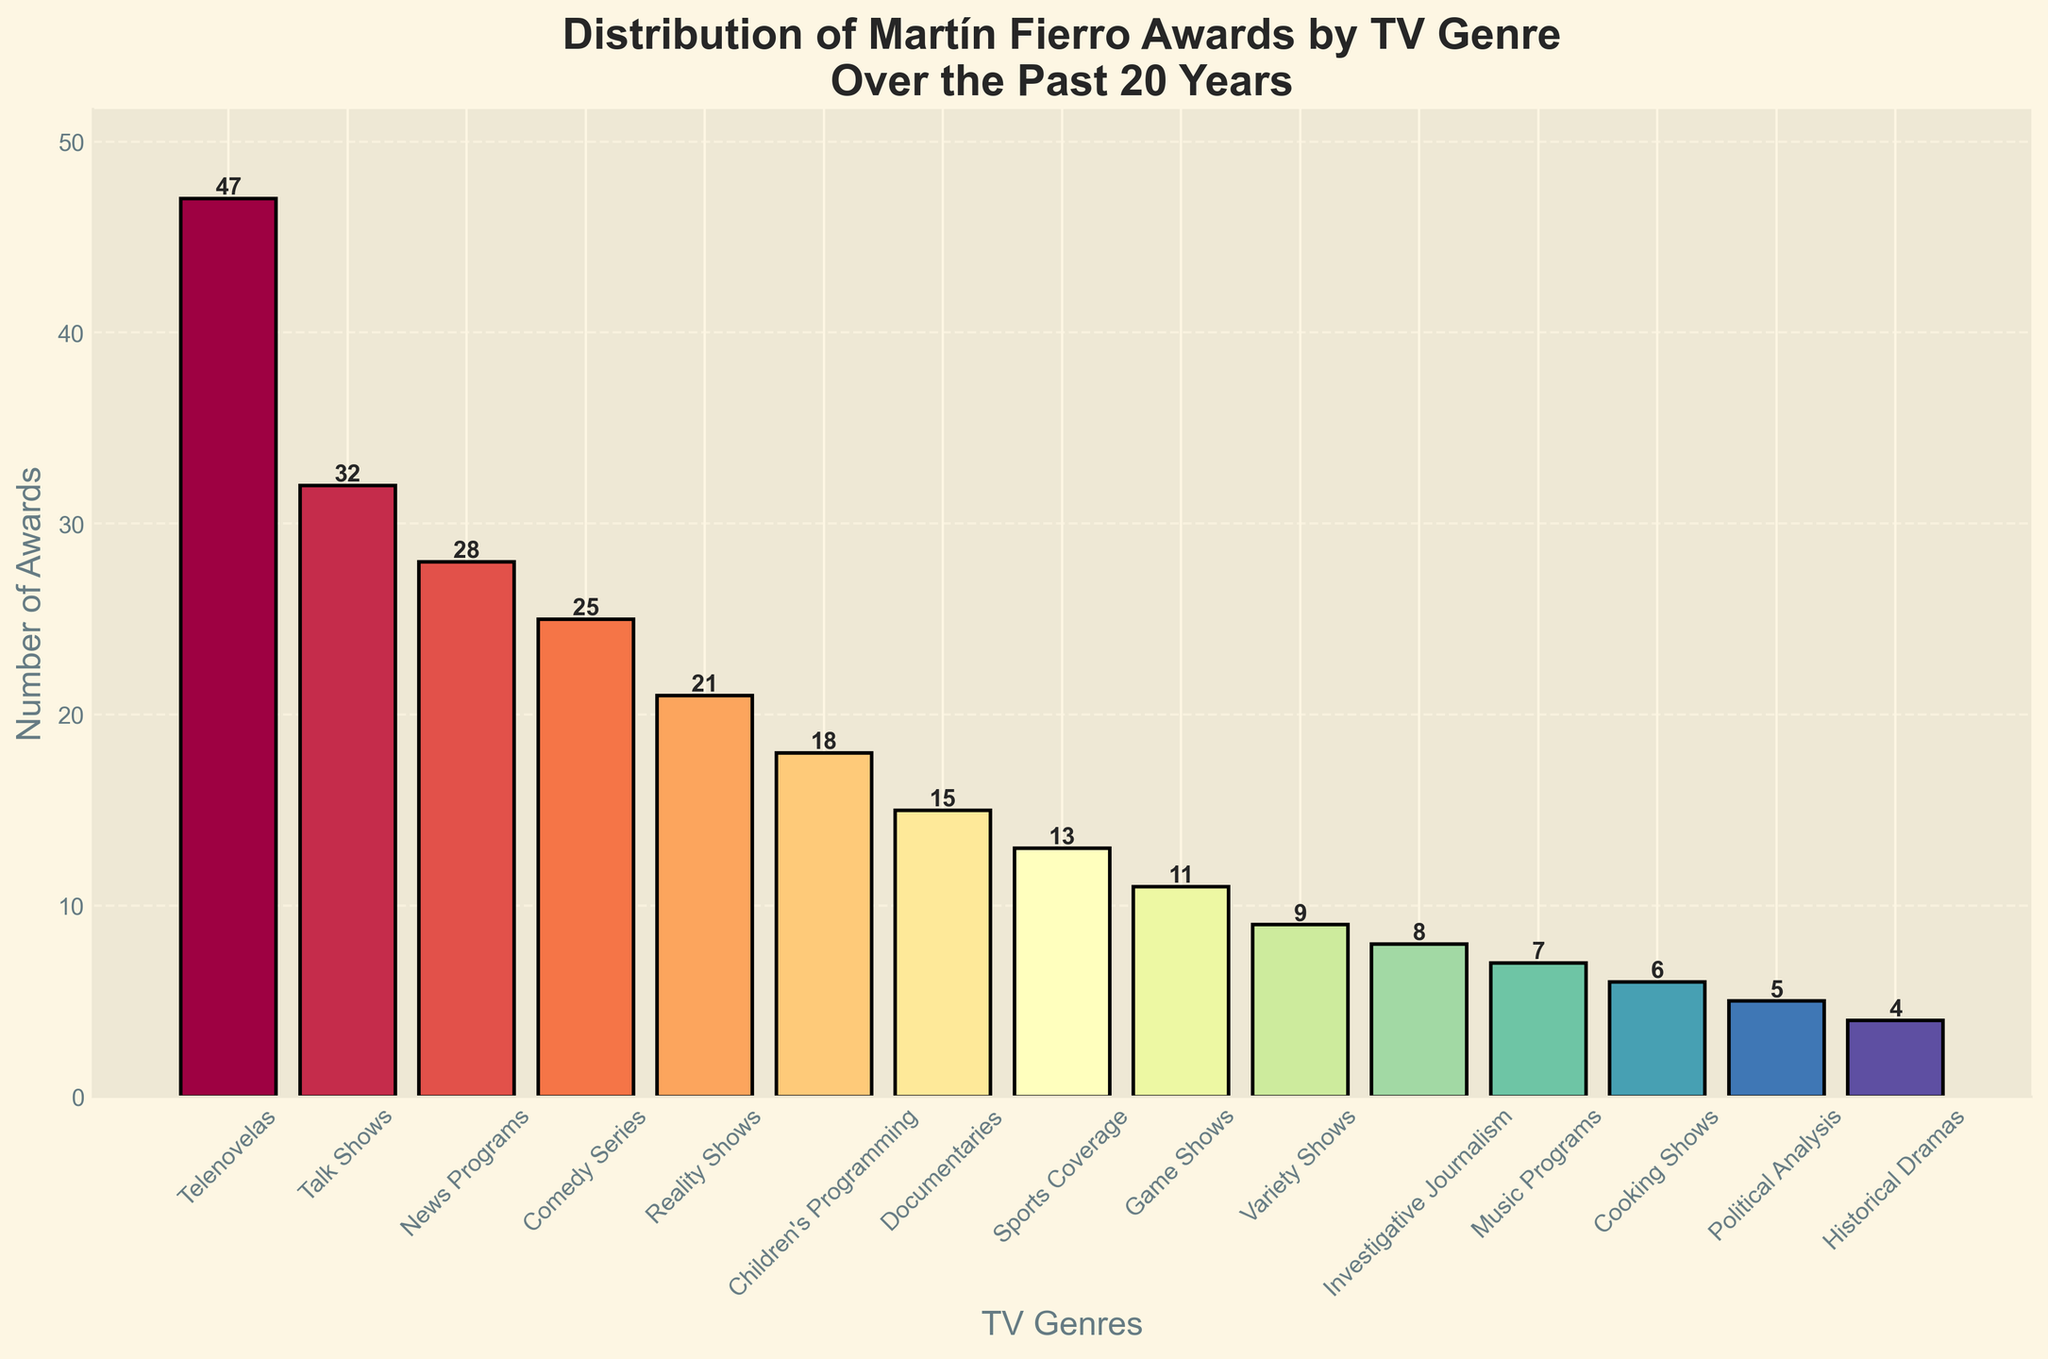Which TV genre has received the most Martín Fierro Awards in the past 20 years? By looking at the bar chart, the tallest bar corresponds to Telenovelas, indicating that this genre has received the most awards.
Answer: Telenovelas Which genre has received more awards: Talk Shows or Reality Shows? Compare the height of the bars for Talk Shows and Reality Shows. The bar for Talk Shows is taller, indicating that Talk Shows have received more awards.
Answer: Talk Shows What's the difference in the number of awards between the genres with the most and the least awards? The genre with the most awards is Telenovelas with 47, and the genre with the least awards is Historical Dramas with 4. The difference is 47 - 4.
Answer: 43 What is the median number of awards for all the genres? Arrange the number of awards in ascending order: [4, 5, 6, 7, 8, 9, 11, 13, 15, 18, 21, 25, 28, 32, 47]. The middle value (median) in this list (7th value) is 13.
Answer: 13 Which genre is represented by the bar colored in the darkest hue? The bar chart uses a color gradient from the color map. The darkest bar is the one with the highest value, which corresponds to Telenovelas.
Answer: Telenovelas What percentage of the total awards have Telenovelas received? First, sum all the awards: 47 + 32 + 28 + 25 + 21 + 18 + 15 + 13 + 11 + 9 + 8 + 7 + 6 + 5 + 4 = 249. Telenovelas received 47 awards. The percentage is (47 / 249) × 100.
Answer: 18.88% How many genres have received more than 20 awards? Count the bars with height greater than 20. This includes Telenovelas (47), Talk Shows (32), News Programs (28), Comedy Series (25), and Reality Shows (21). There are 5 genres in total.
Answer: 5 Which bar is the shortest in the chart? The shortest bar corresponds to Historical Dramas, with a value of 4 awards.
Answer: Historical Dramas Are there more awards in Children's Programming or Game Shows, and by how many? Compare the height of the bars for Children's Programming and Game Shows. Children's Programming has 18 awards, while Game Shows has 11. Difference is 18 - 11.
Answer: Children's Programming, by 7 What is the average number of awards per genre? Sum all the awards: 249. There are 15 genres. The average number of awards is 249 / 15.
Answer: 16.6 